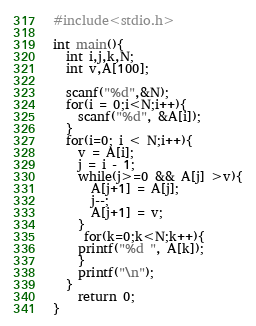Convert code to text. <code><loc_0><loc_0><loc_500><loc_500><_C_>#include<stdio.h>

int main(){
  int i,j,k,N;
  int v,A[100];

  scanf("%d",&N);
  for(i = 0;i<N;i++){
    scanf("%d", &A[i]);
  }
  for(i=0; i < N;i++){
    v = A[i];
    j = i - 1;
    while(j>=0 && A[j] >v){
      A[j+1] = A[j];
      j--;
      A[j+1] = v;
    }
     for(k=0;k<N;k++){
    printf("%d ", A[k]);
    }
    printf("\n");
  }
    return 0;
}</code> 